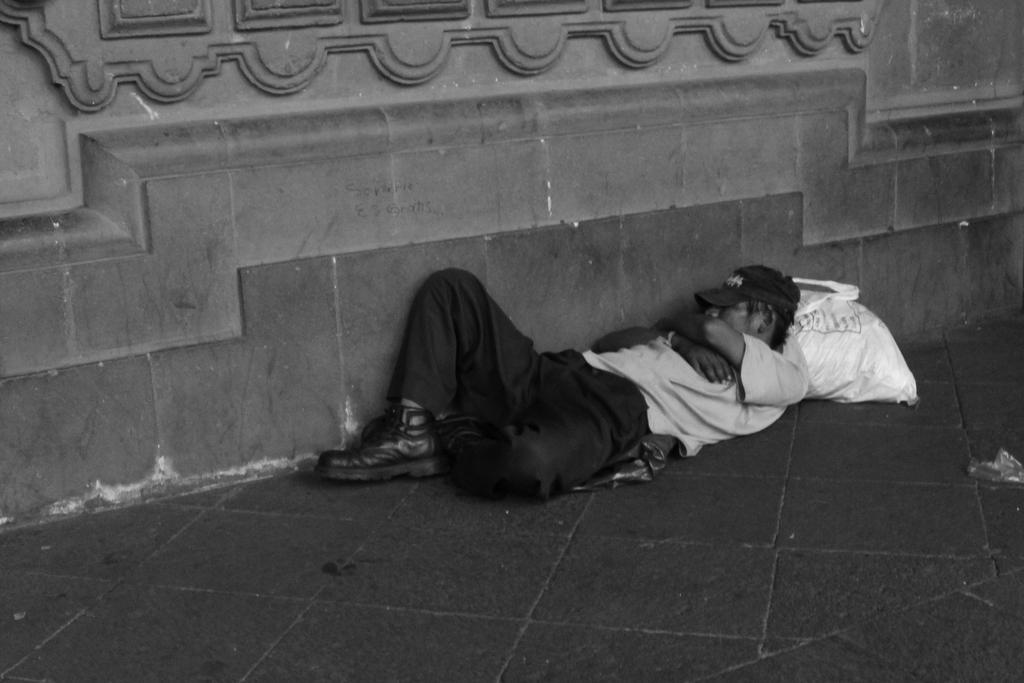In one or two sentences, can you explain what this image depicts? In this picture I can see a man is lying on the ground. The man is wearing a cap, shoes, t-shirt and pants. This picture is black and white in color. 